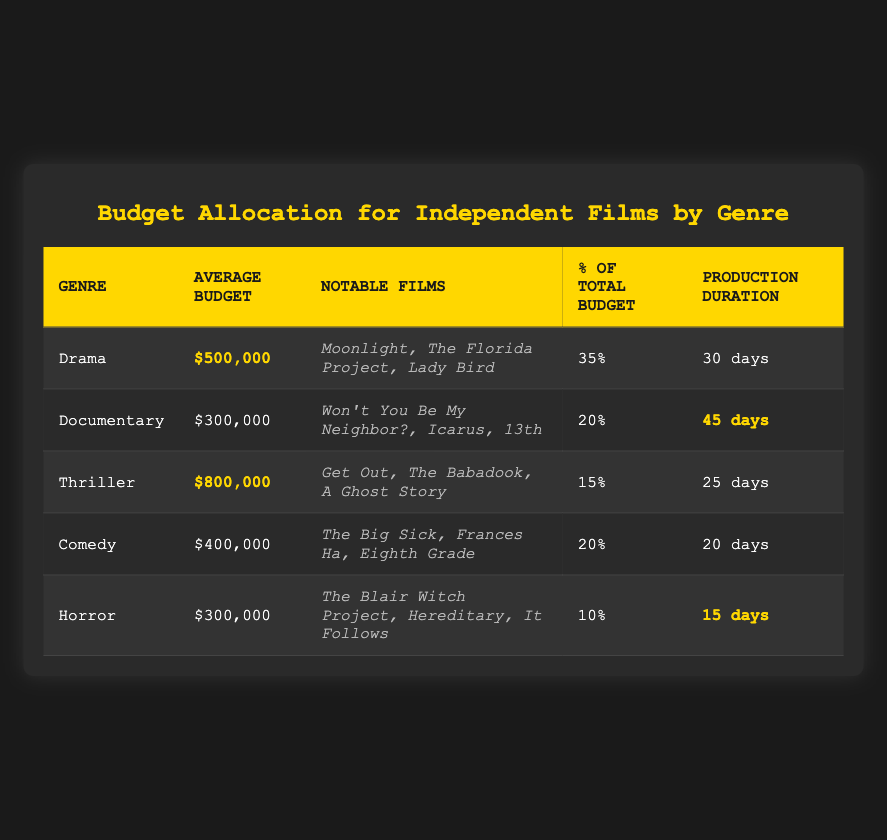What is the average budget for independent films in the Thriller genre? The table shows that the average budget listed for the Thriller genre is $800,000
Answer: $800,000 Which genre has the highest production duration? The production duration for each genre is listed, and the longest duration is 45 days for Documentary
Answer: 45 days What percentage of the total independent budget is allocated to Drama films? From the table, it states that Drama films receive 35% of the total independent budget
Answer: 35% Is the average budget for Comedy films higher than for Horror films? The average budget for Comedy is $400,000, while Horror has $300,000. Since $400,000 is greater than $300,000, the answer is yes
Answer: Yes Which genre has the lowest percentage of total independent budget allocation? According to the table, Horror films have the lowest allocation at 10%
Answer: 10% How much more budget, on average, is allocated to Thriller films compared to Drama films? The average budget for Thriller is $800,000, and for Drama, it's $500,000. Calculating the difference gives $800,000 - $500,000 = $300,000
Answer: $300,000 What is the combined percentage of the total budget allocated to Documentary and Comedy films? The table shows Documentary at 20% and Comedy also at 20%. Adding these together gives 20% + 20% = 40%
Answer: 40% How many notable films are listed for the Horror genre? The table lists three notable films for the Horror genre: "The Blair Witch Project", "Hereditary", and "It Follows"
Answer: 3 Which genre has both the highest average budget and the shortest production duration? The Thriller genre has the highest average budget of $800,000 and a production duration of 25 days, which is shorter than Drama at 30 days. Therefore, the answer is Thriller
Answer: Thriller What is the average budget of all genres combined? To find the average budget, sum all the average budgets ($500,000 + $300,000 + $800,000 + $400,000 + $300,000 = $2,300,000) and divide by the number of genres (5). Thus, $2,300,000 / 5 = $460,000
Answer: $460,000 